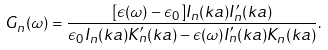<formula> <loc_0><loc_0><loc_500><loc_500>G _ { n } ( \omega ) = \frac { [ \epsilon ( \omega ) - \epsilon _ { 0 } ] I _ { n } ( k a ) I _ { n } ^ { \prime } ( k a ) } { \epsilon _ { 0 } I _ { n } ( k a ) K _ { n } ^ { \prime } ( k a ) - \epsilon ( \omega ) I _ { n } ^ { \prime } ( k a ) K _ { n } ( k a ) } .</formula> 